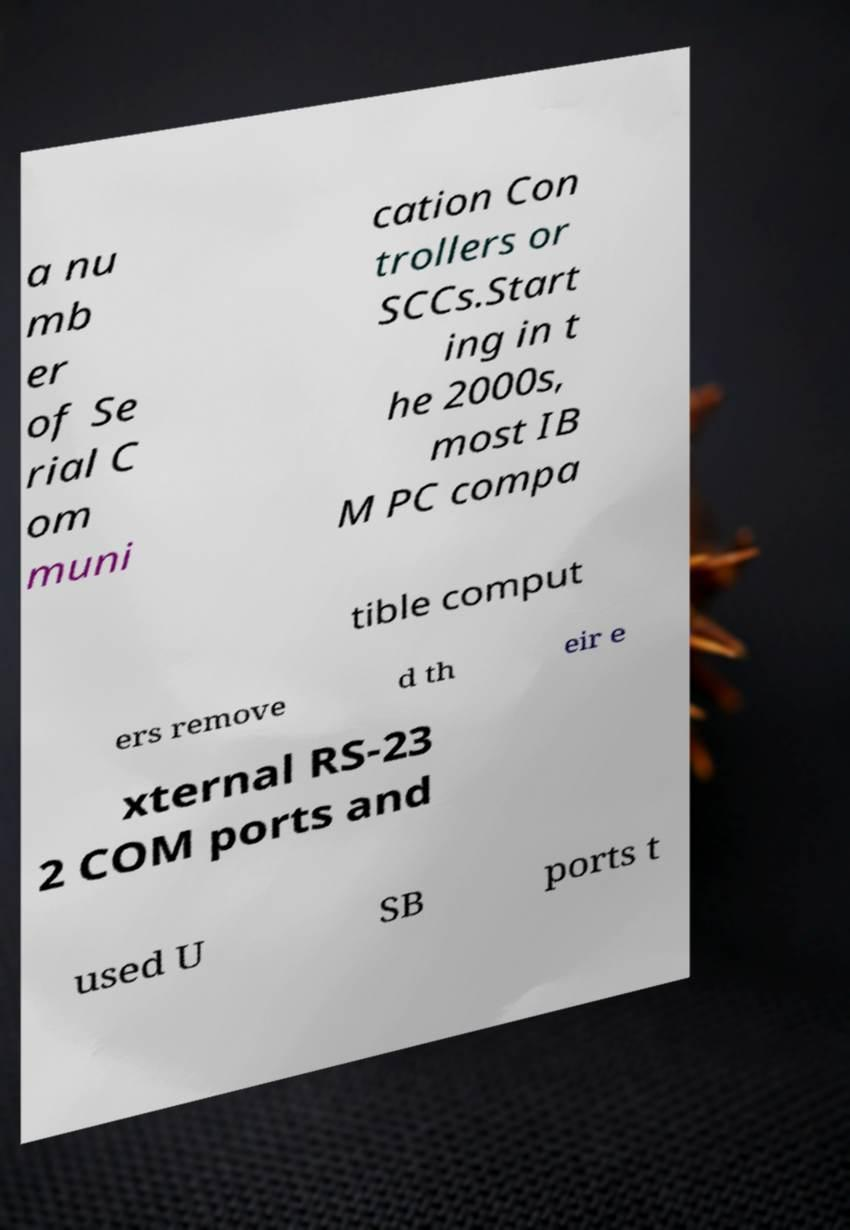What messages or text are displayed in this image? I need them in a readable, typed format. a nu mb er of Se rial C om muni cation Con trollers or SCCs.Start ing in t he 2000s, most IB M PC compa tible comput ers remove d th eir e xternal RS-23 2 COM ports and used U SB ports t 